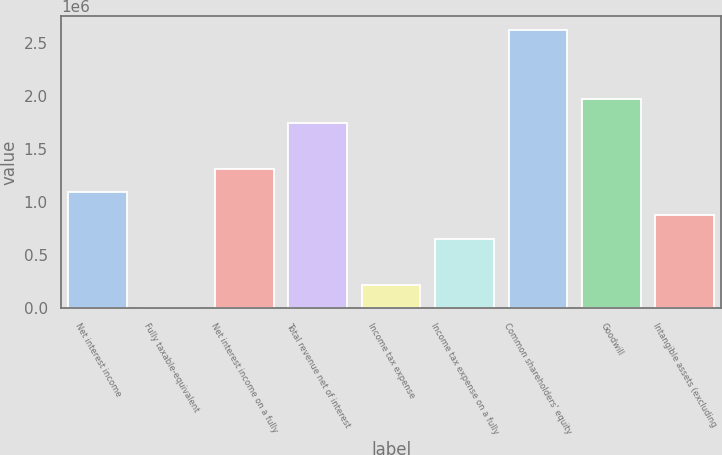Convert chart. <chart><loc_0><loc_0><loc_500><loc_500><bar_chart><fcel>Net interest income<fcel>Fully taxable-equivalent<fcel>Net interest income on a fully<fcel>Total revenue net of interest<fcel>Income tax expense<fcel>Income tax expense on a fully<fcel>Common shareholders' equity<fcel>Goodwill<fcel>Intangible assets (excluding<nl><fcel>1.09297e+06<fcel>215<fcel>1.31152e+06<fcel>1.74862e+06<fcel>218766<fcel>655868<fcel>2.62283e+06<fcel>1.96717e+06<fcel>874419<nl></chart> 